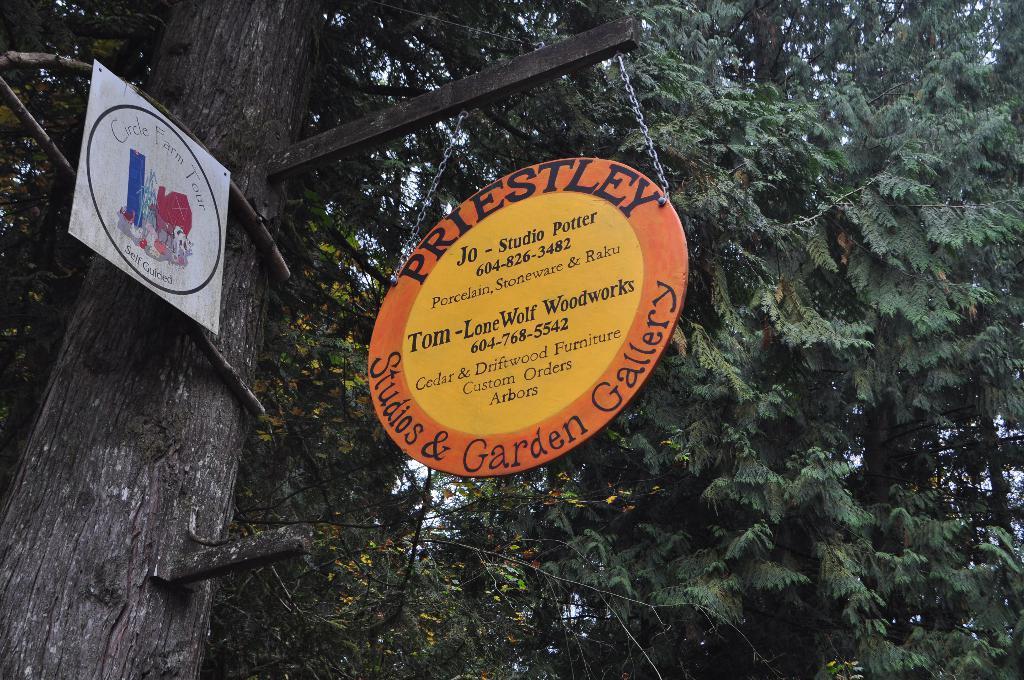How would you summarize this image in a sentence or two? In this image we can see a tree to which there are some boards attached, in which some words are written and top of the image there are some leaves. 